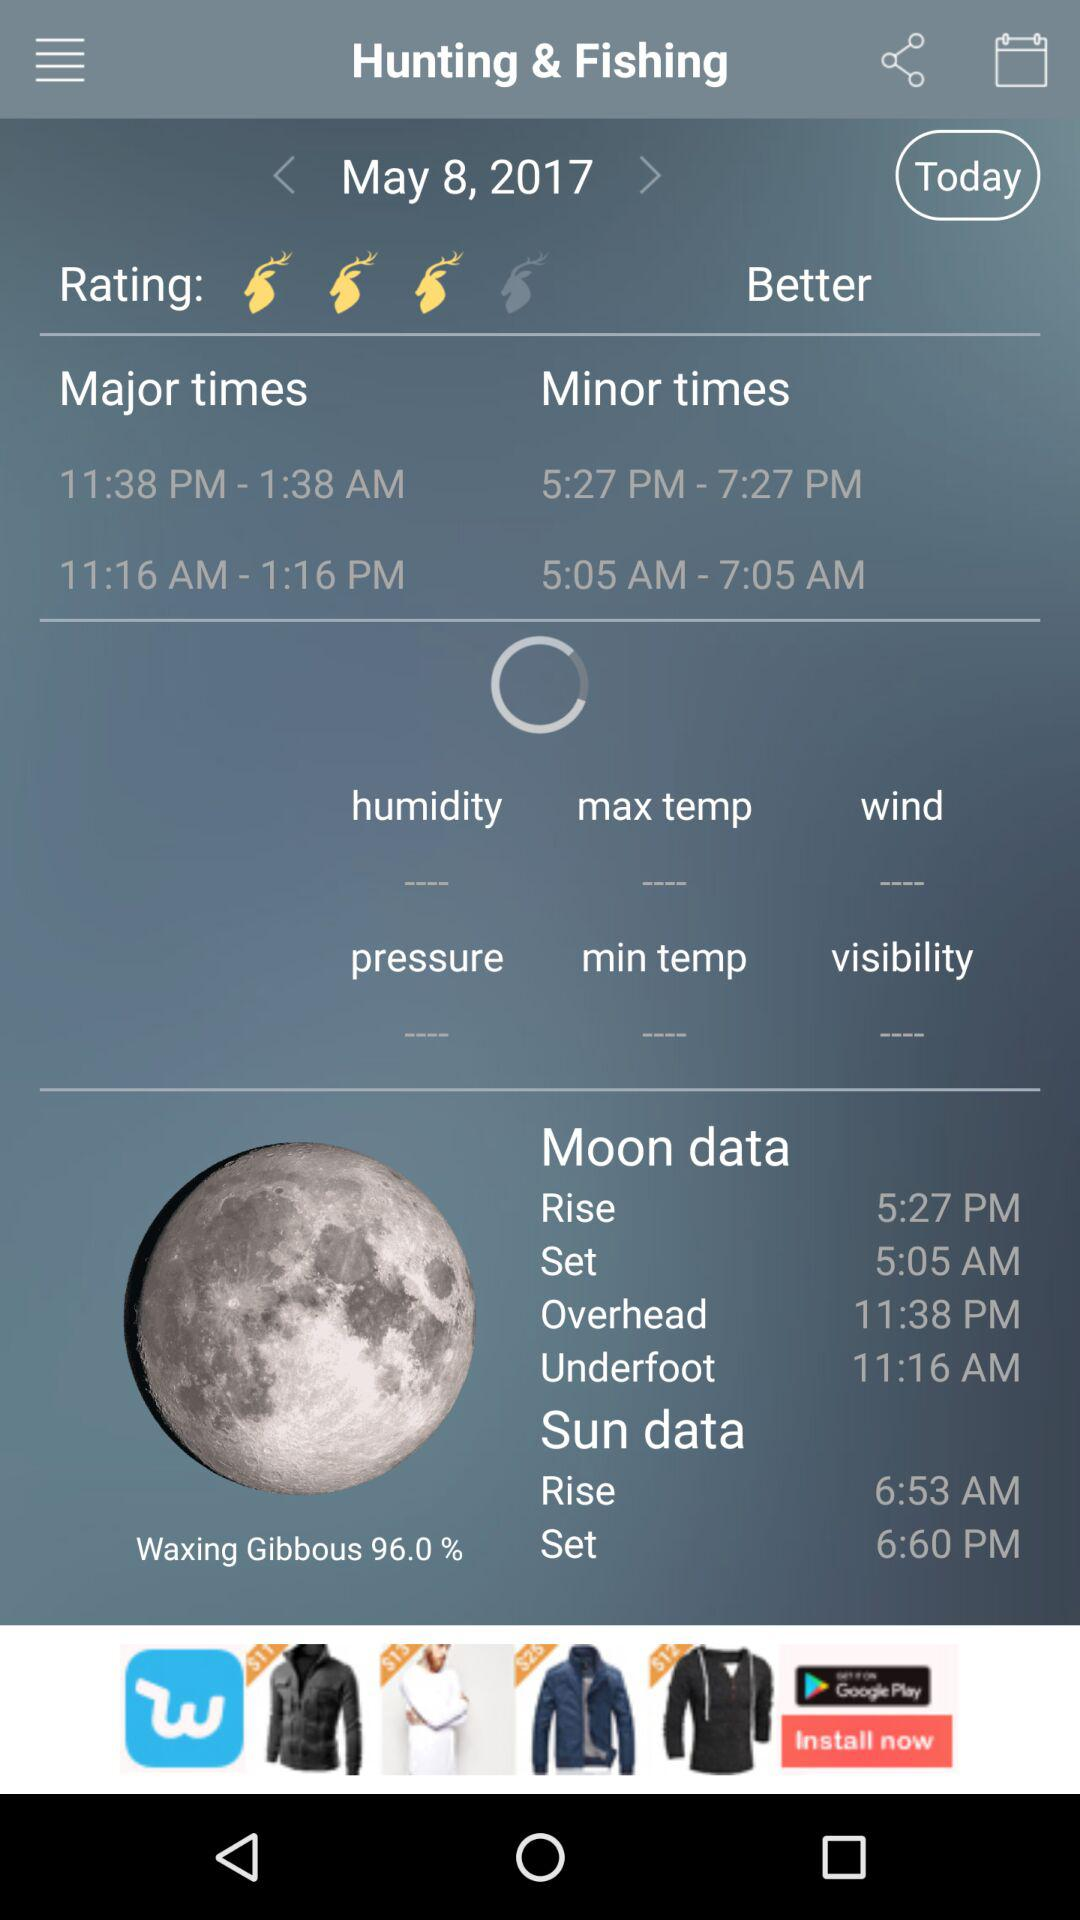What is the sun rise time? The sun rise time is 6:53 AM. 